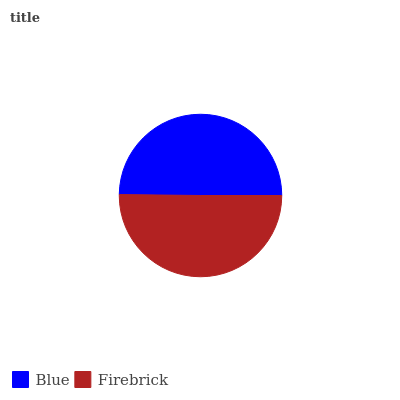Is Blue the minimum?
Answer yes or no. Yes. Is Firebrick the maximum?
Answer yes or no. Yes. Is Firebrick the minimum?
Answer yes or no. No. Is Firebrick greater than Blue?
Answer yes or no. Yes. Is Blue less than Firebrick?
Answer yes or no. Yes. Is Blue greater than Firebrick?
Answer yes or no. No. Is Firebrick less than Blue?
Answer yes or no. No. Is Firebrick the high median?
Answer yes or no. Yes. Is Blue the low median?
Answer yes or no. Yes. Is Blue the high median?
Answer yes or no. No. Is Firebrick the low median?
Answer yes or no. No. 